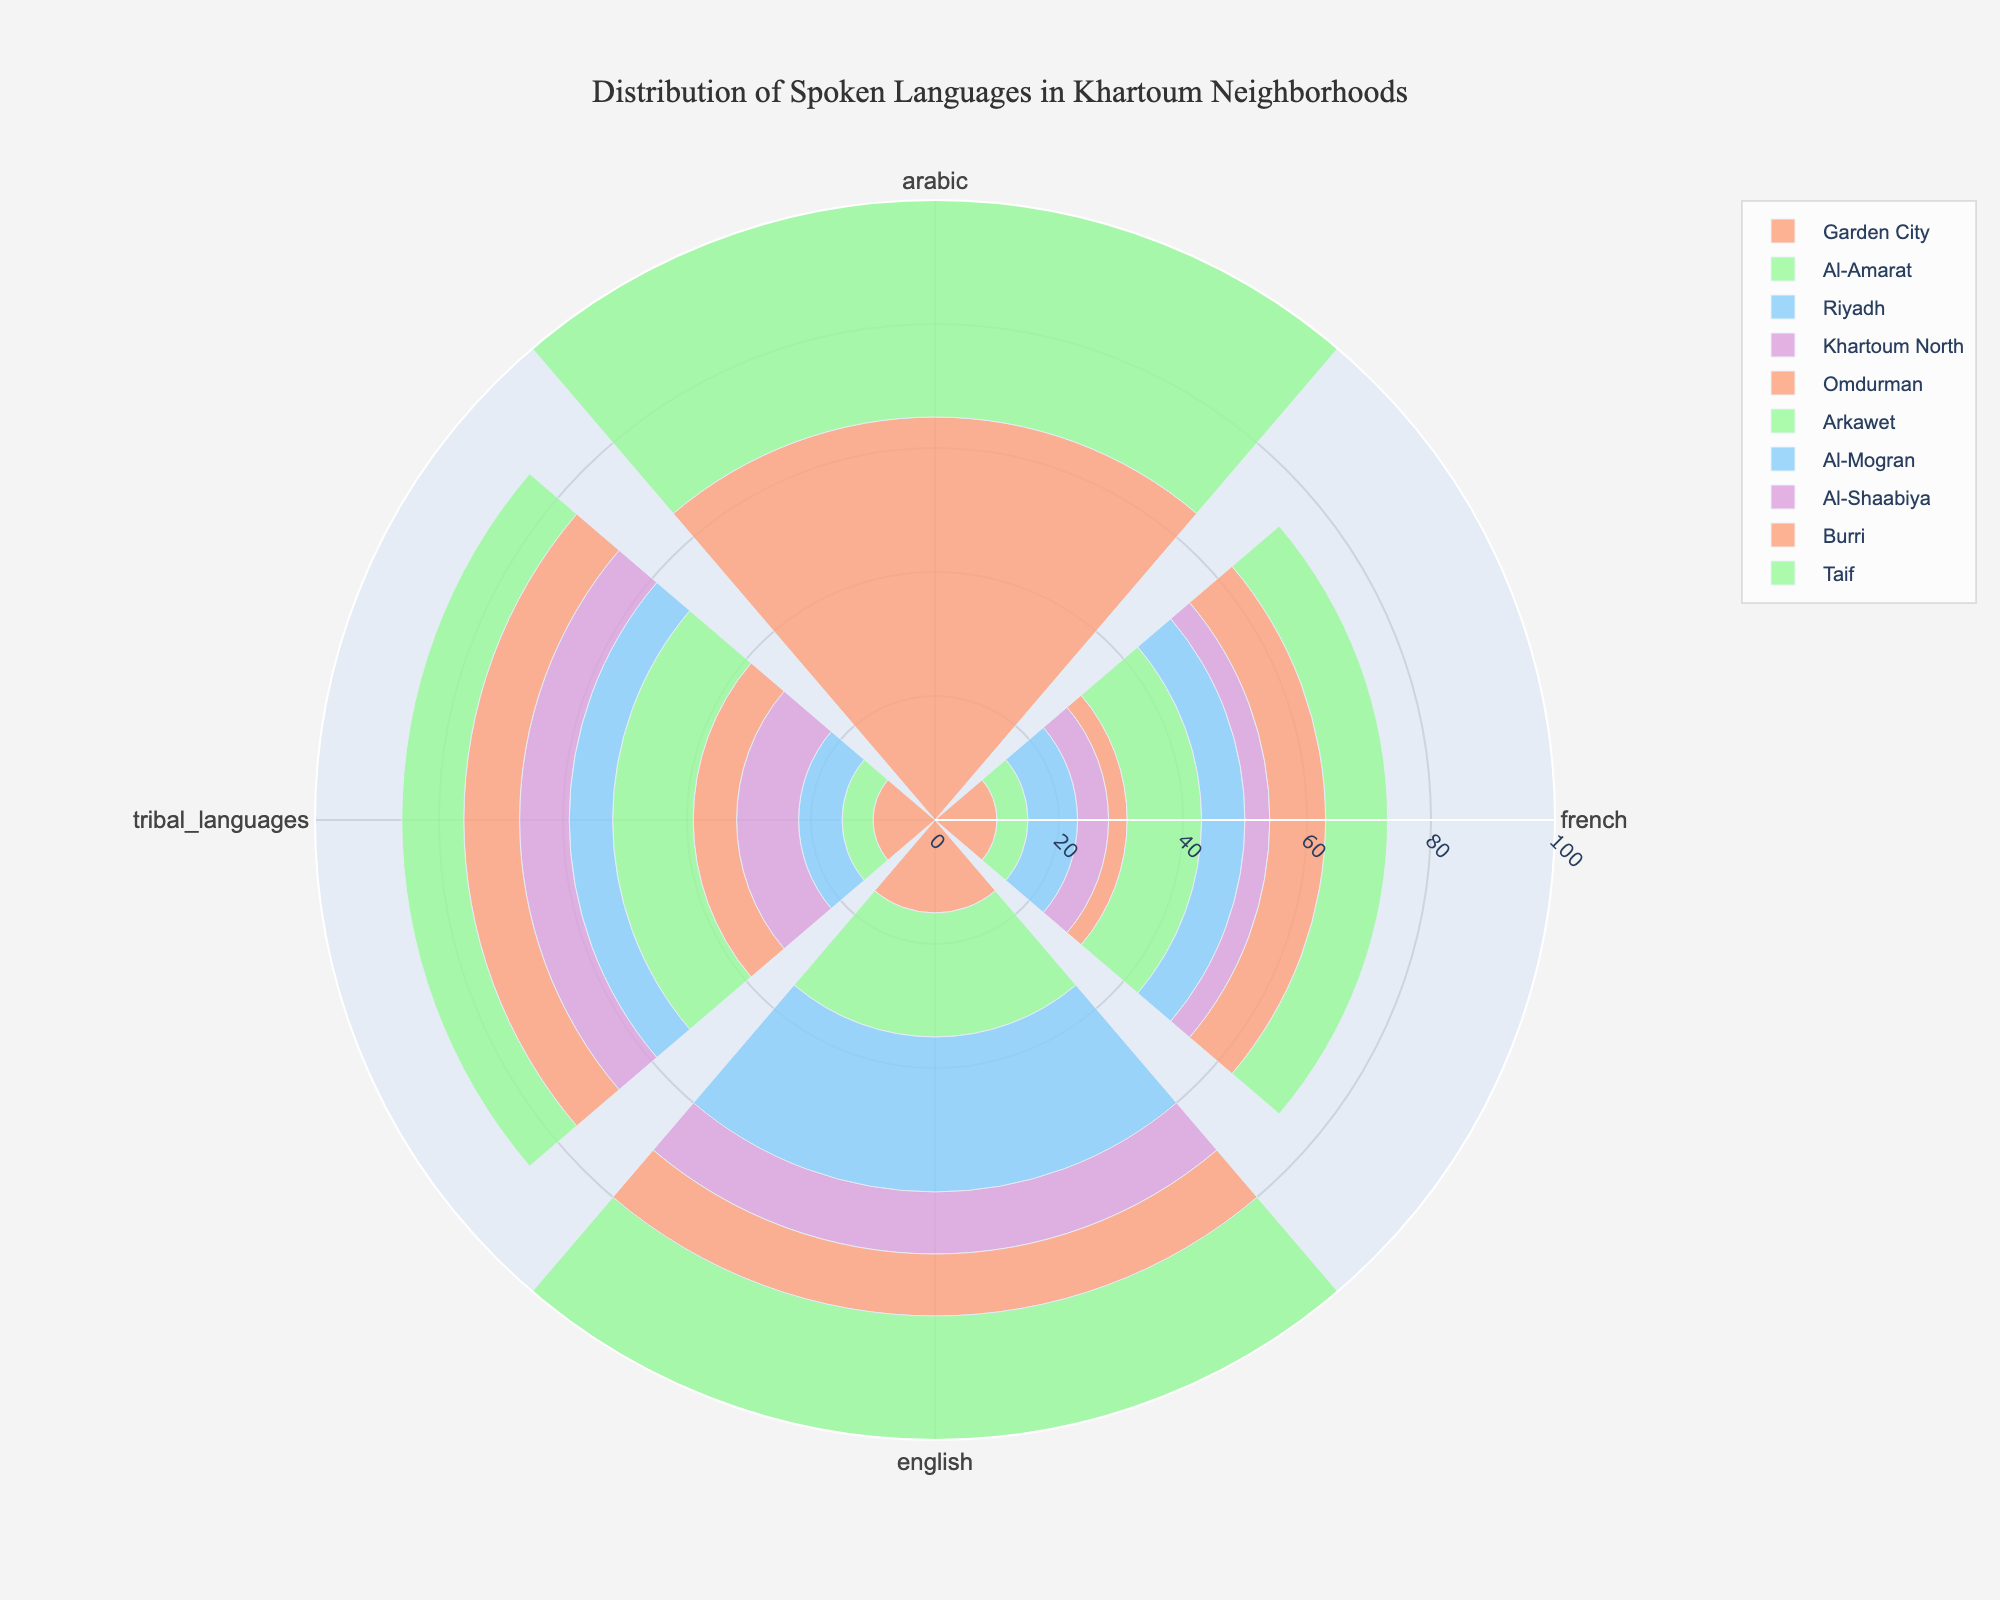What is the title of the figure? The title is located at the top center of the figure, easily visible and written in a larger, bold font relative to other text elements.
Answer: Distribution of Spoken Languages in Khartoum Neighborhoods How many different neighborhoods are represented in the figure? The legend at the right-hand side of the figure lists all the neighborhoods represented. By counting the entries in the legend, you can find the total number.
Answer: 10 Which neighborhood has the highest percentage of French speakers? By examining each subplot, you can identify that Arkawet has the tallest bar for French, indicating the highest percentage.
Answer: Arkawet In which neighborhood is the percentage of Arabic and tribal languages equal? Review each subplot for neighborhoods where the bars for Arabic and tribal languages are the same height. Garden City and Taif have equal percentages.
Answer: Garden City and Taif What is the average percentage of English speakers across all neighborhoods? Sum the percentages of English speakers across all neighborhoods and divide this sum by the number of neighborhoods (10). The calculation is (15+20+25+10+10+20+18+15+20+15)/10 = 16.8.
Answer: 16.8 Which neighborhood has the lowest percentage of French speakers? Check each subplot for the smallest bar representing French speakers. Omdurman has the lowest percentage of French speakers.
Answer: Omdurman Compare the percentages of Arabic and English speakers in Khartoum North. Which is greater and by how much? By looking at the subplot for Khartoum North, you see Arabic has 75% and English has 10%. The difference is 75 - 10 = 65.
Answer: Arabic is greater by 65 List the neighborhoods with higher percentages of tribal languages than French. Compare each subplot, focusing on the bars for tribal languages and French. Garden City, Riyadh, Arkawet, Burri have higher percentages for tribal languages than for French.
Answer: Garden City, Riyadh, Arkawet, Burri Which language has the most consistent percentage across all neighborhoods? Evaluate each language by comparing its bar heights across all subplots. Arabic has relatively consistent percentages across neighborhoods.
Answer: Arabic 